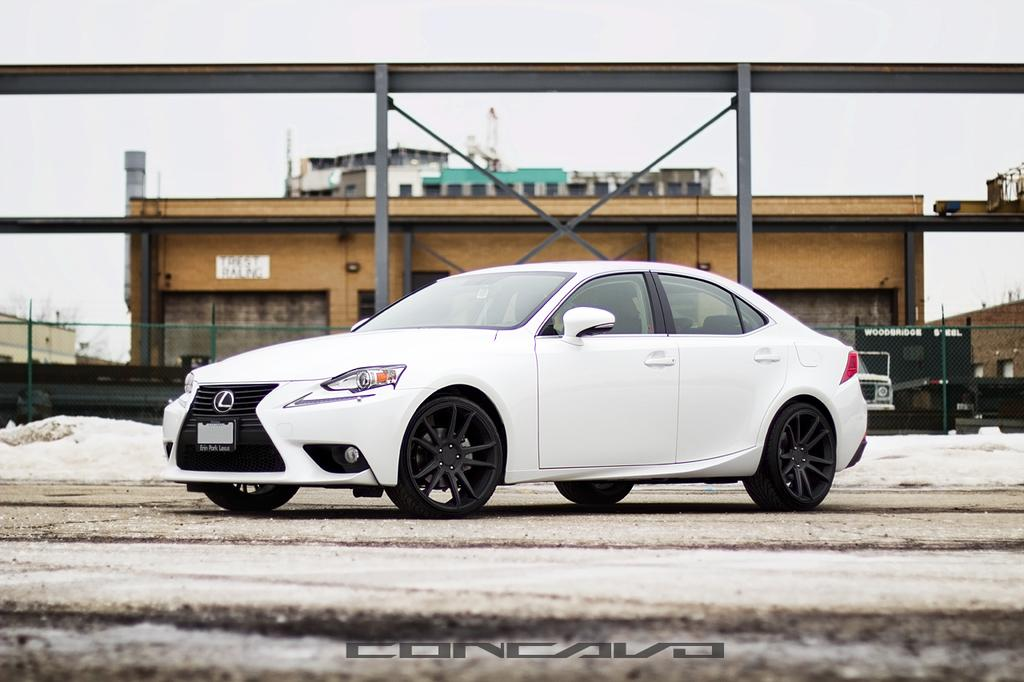What types of objects are present in the image? There are vehicles, a fence, and buildings in the image. What is the weather condition in the image? There is snow in the image, indicating a cold or wintry condition. What can be seen in the background of the image? The sky is visible in the background of the image. Is there any watermark on the image? Yes, there is a watermark on the image. Can you hear any music playing in the image? There is no audio or sound present in the image, so it is not possible to hear any music. Is there a tiger visible in the image? No, there is no tiger present in the image. 